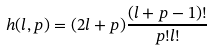Convert formula to latex. <formula><loc_0><loc_0><loc_500><loc_500>h ( l , p ) = ( 2 l + p ) \frac { ( l + p - 1 ) ! } { p ! l ! }</formula> 